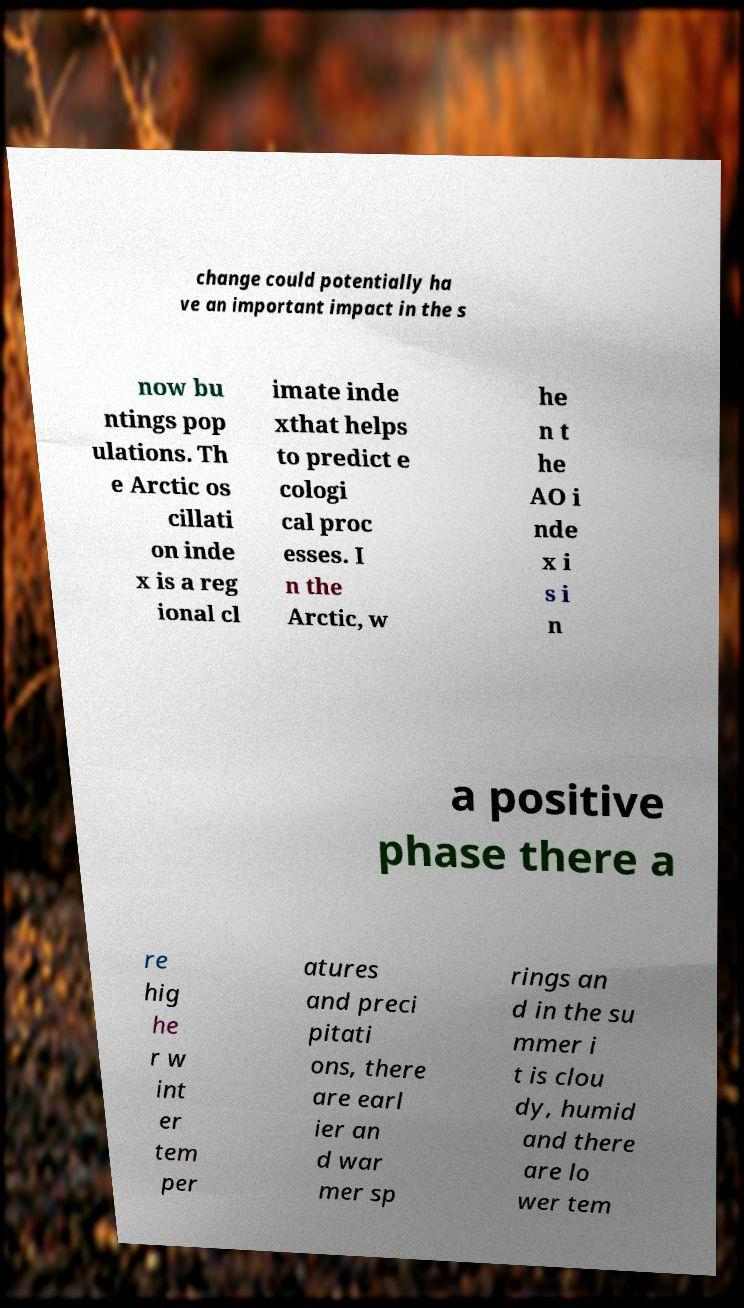I need the written content from this picture converted into text. Can you do that? change could potentially ha ve an important impact in the s now bu ntings pop ulations. Th e Arctic os cillati on inde x is a reg ional cl imate inde xthat helps to predict e cologi cal proc esses. I n the Arctic, w he n t he AO i nde x i s i n a positive phase there a re hig he r w int er tem per atures and preci pitati ons, there are earl ier an d war mer sp rings an d in the su mmer i t is clou dy, humid and there are lo wer tem 